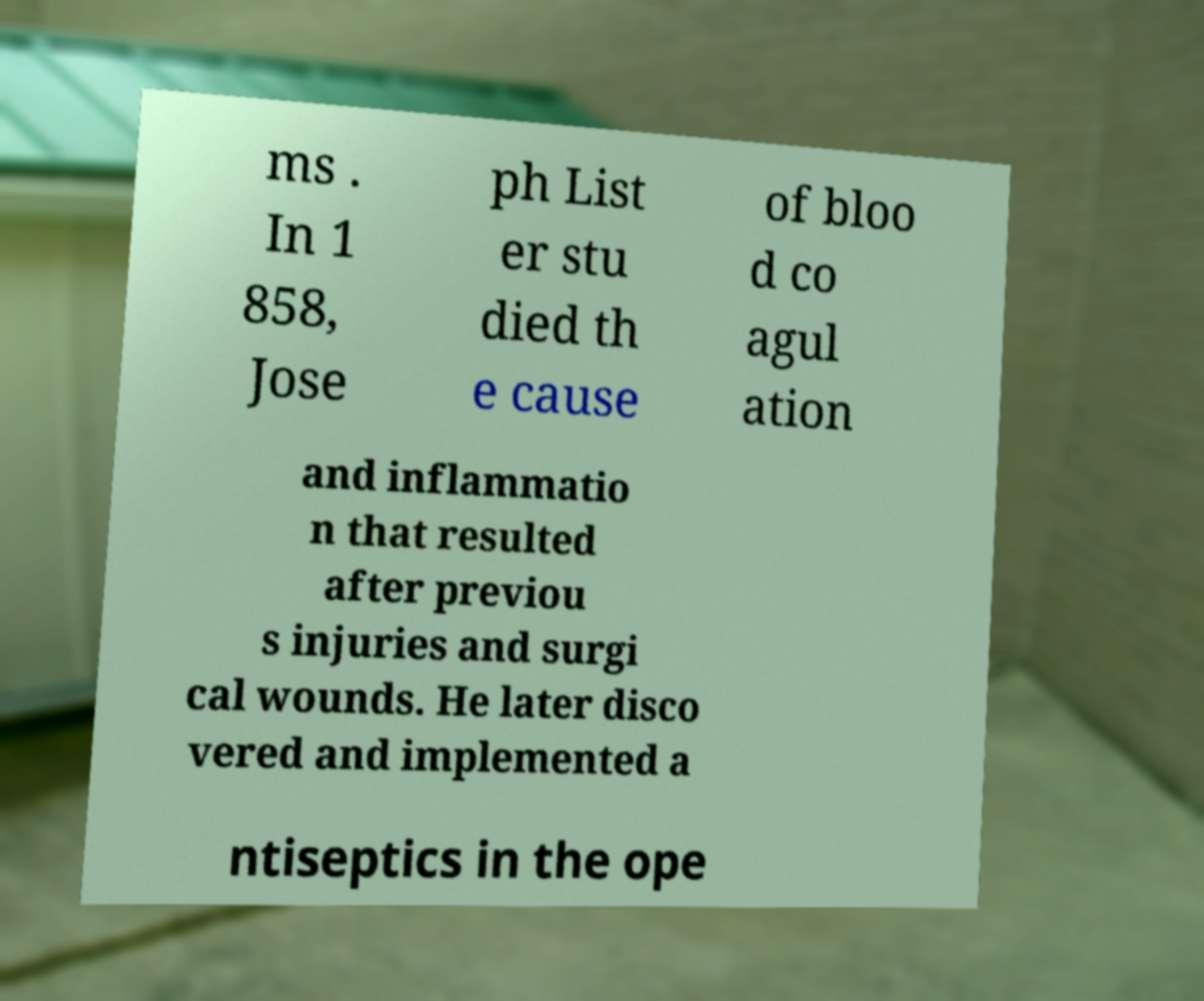Please read and relay the text visible in this image. What does it say? ms . In 1 858, Jose ph List er stu died th e cause of bloo d co agul ation and inflammatio n that resulted after previou s injuries and surgi cal wounds. He later disco vered and implemented a ntiseptics in the ope 